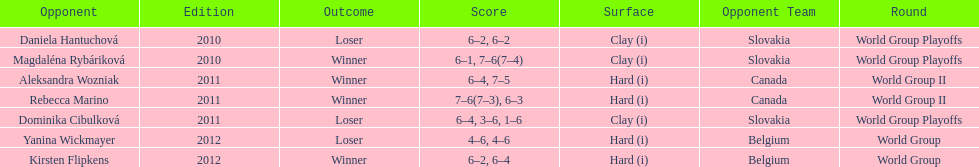Number of games in the match against dominika cibulkova? 3. 